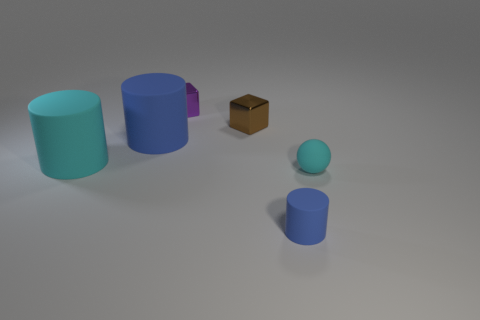Subtract all brown cylinders. Subtract all blue spheres. How many cylinders are left? 3 Add 2 small shiny blocks. How many objects exist? 8 Subtract all blocks. How many objects are left? 4 Add 4 large cyan rubber things. How many large cyan rubber things exist? 5 Subtract 0 purple spheres. How many objects are left? 6 Subtract all brown cubes. Subtract all metal objects. How many objects are left? 3 Add 5 tiny blue cylinders. How many tiny blue cylinders are left? 6 